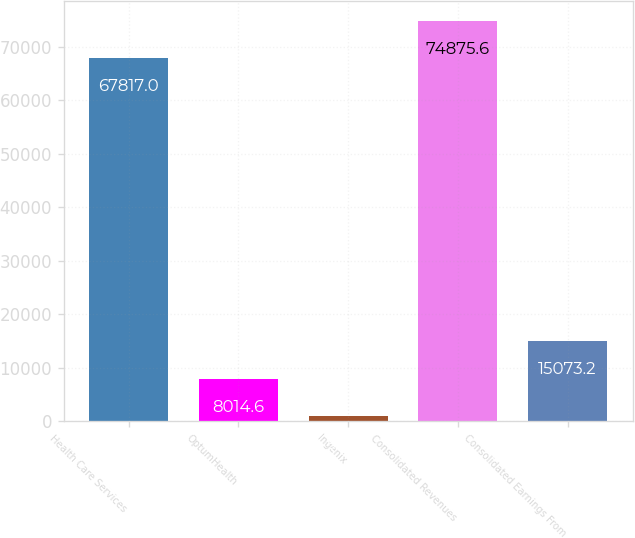<chart> <loc_0><loc_0><loc_500><loc_500><bar_chart><fcel>Health Care Services<fcel>OptumHealth<fcel>Ingenix<fcel>Consolidated Revenues<fcel>Consolidated Earnings From<nl><fcel>67817<fcel>8014.6<fcel>956<fcel>74875.6<fcel>15073.2<nl></chart> 